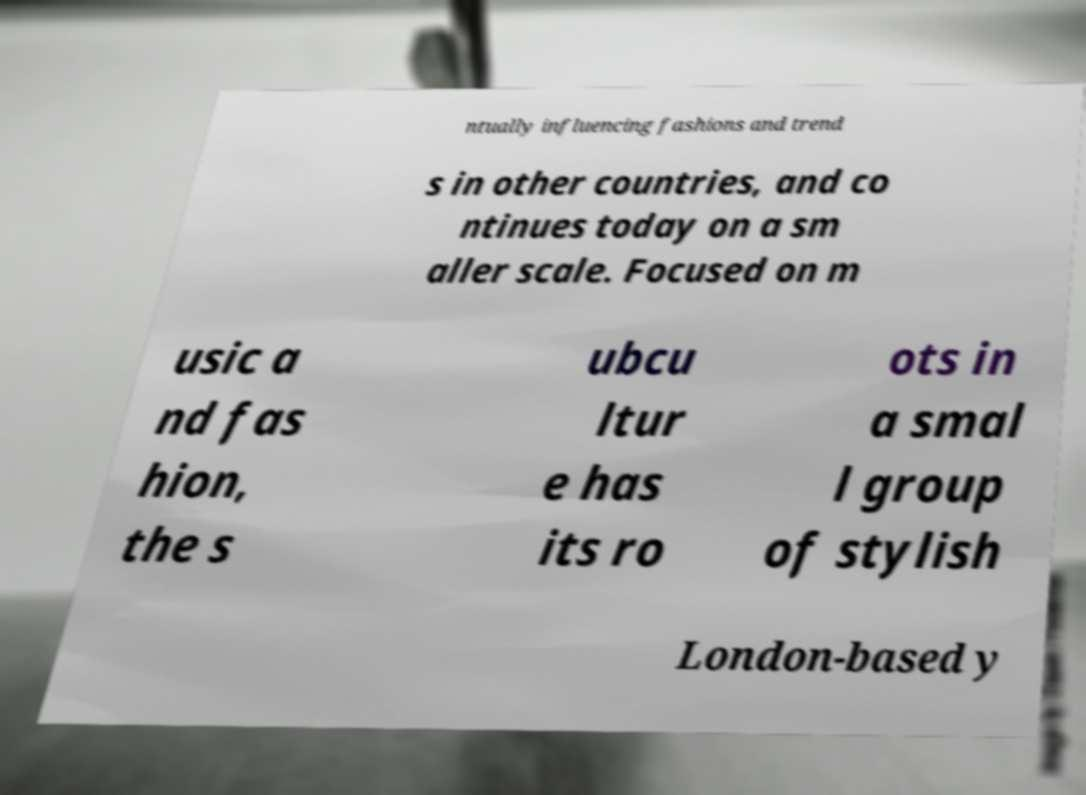What messages or text are displayed in this image? I need them in a readable, typed format. ntually influencing fashions and trend s in other countries, and co ntinues today on a sm aller scale. Focused on m usic a nd fas hion, the s ubcu ltur e has its ro ots in a smal l group of stylish London-based y 